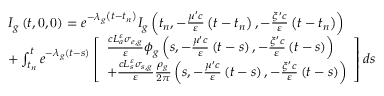Convert formula to latex. <formula><loc_0><loc_0><loc_500><loc_500>\begin{array} { l } { { I _ { g } \left ( t , 0 , 0 \right ) = e ^ { - \lambda _ { g } \left ( t - t _ { n } \right ) } I _ { g } \left ( t _ { n } , - \frac { \mu ^ { \prime } c } { \varepsilon } \left ( t - t _ { n } \right ) , - \frac { \xi ^ { \prime } c } { \varepsilon } \left ( t - t _ { n } \right ) \right ) } } \\ { { + \int _ { t _ { n } } ^ { t } e ^ { - \lambda _ { g } \left ( t - s \right ) } \left [ \begin{array} { l } { { \frac { c L _ { a } ^ { \varepsilon } \sigma _ { e , g } } { \varepsilon } \phi _ { g } \left ( s , - \frac { \mu ^ { \prime } c } { \varepsilon } \left ( t - s \right ) , - \frac { \xi ^ { \prime } c } { \varepsilon } \left ( t - s \right ) \right ) } } \\ { { + \frac { c L _ { s } ^ { \varepsilon } \sigma _ { s , g } } { \varepsilon } \frac { \rho _ { g } } { 2 \pi } \left ( s , - \frac { \mu ^ { \prime } c } { \varepsilon } \left ( t - s \right ) , - \frac { \xi ^ { \prime } c } { \varepsilon } \left ( t - s \right ) \right ) } } \end{array} \right ] d s } } \end{array}</formula> 